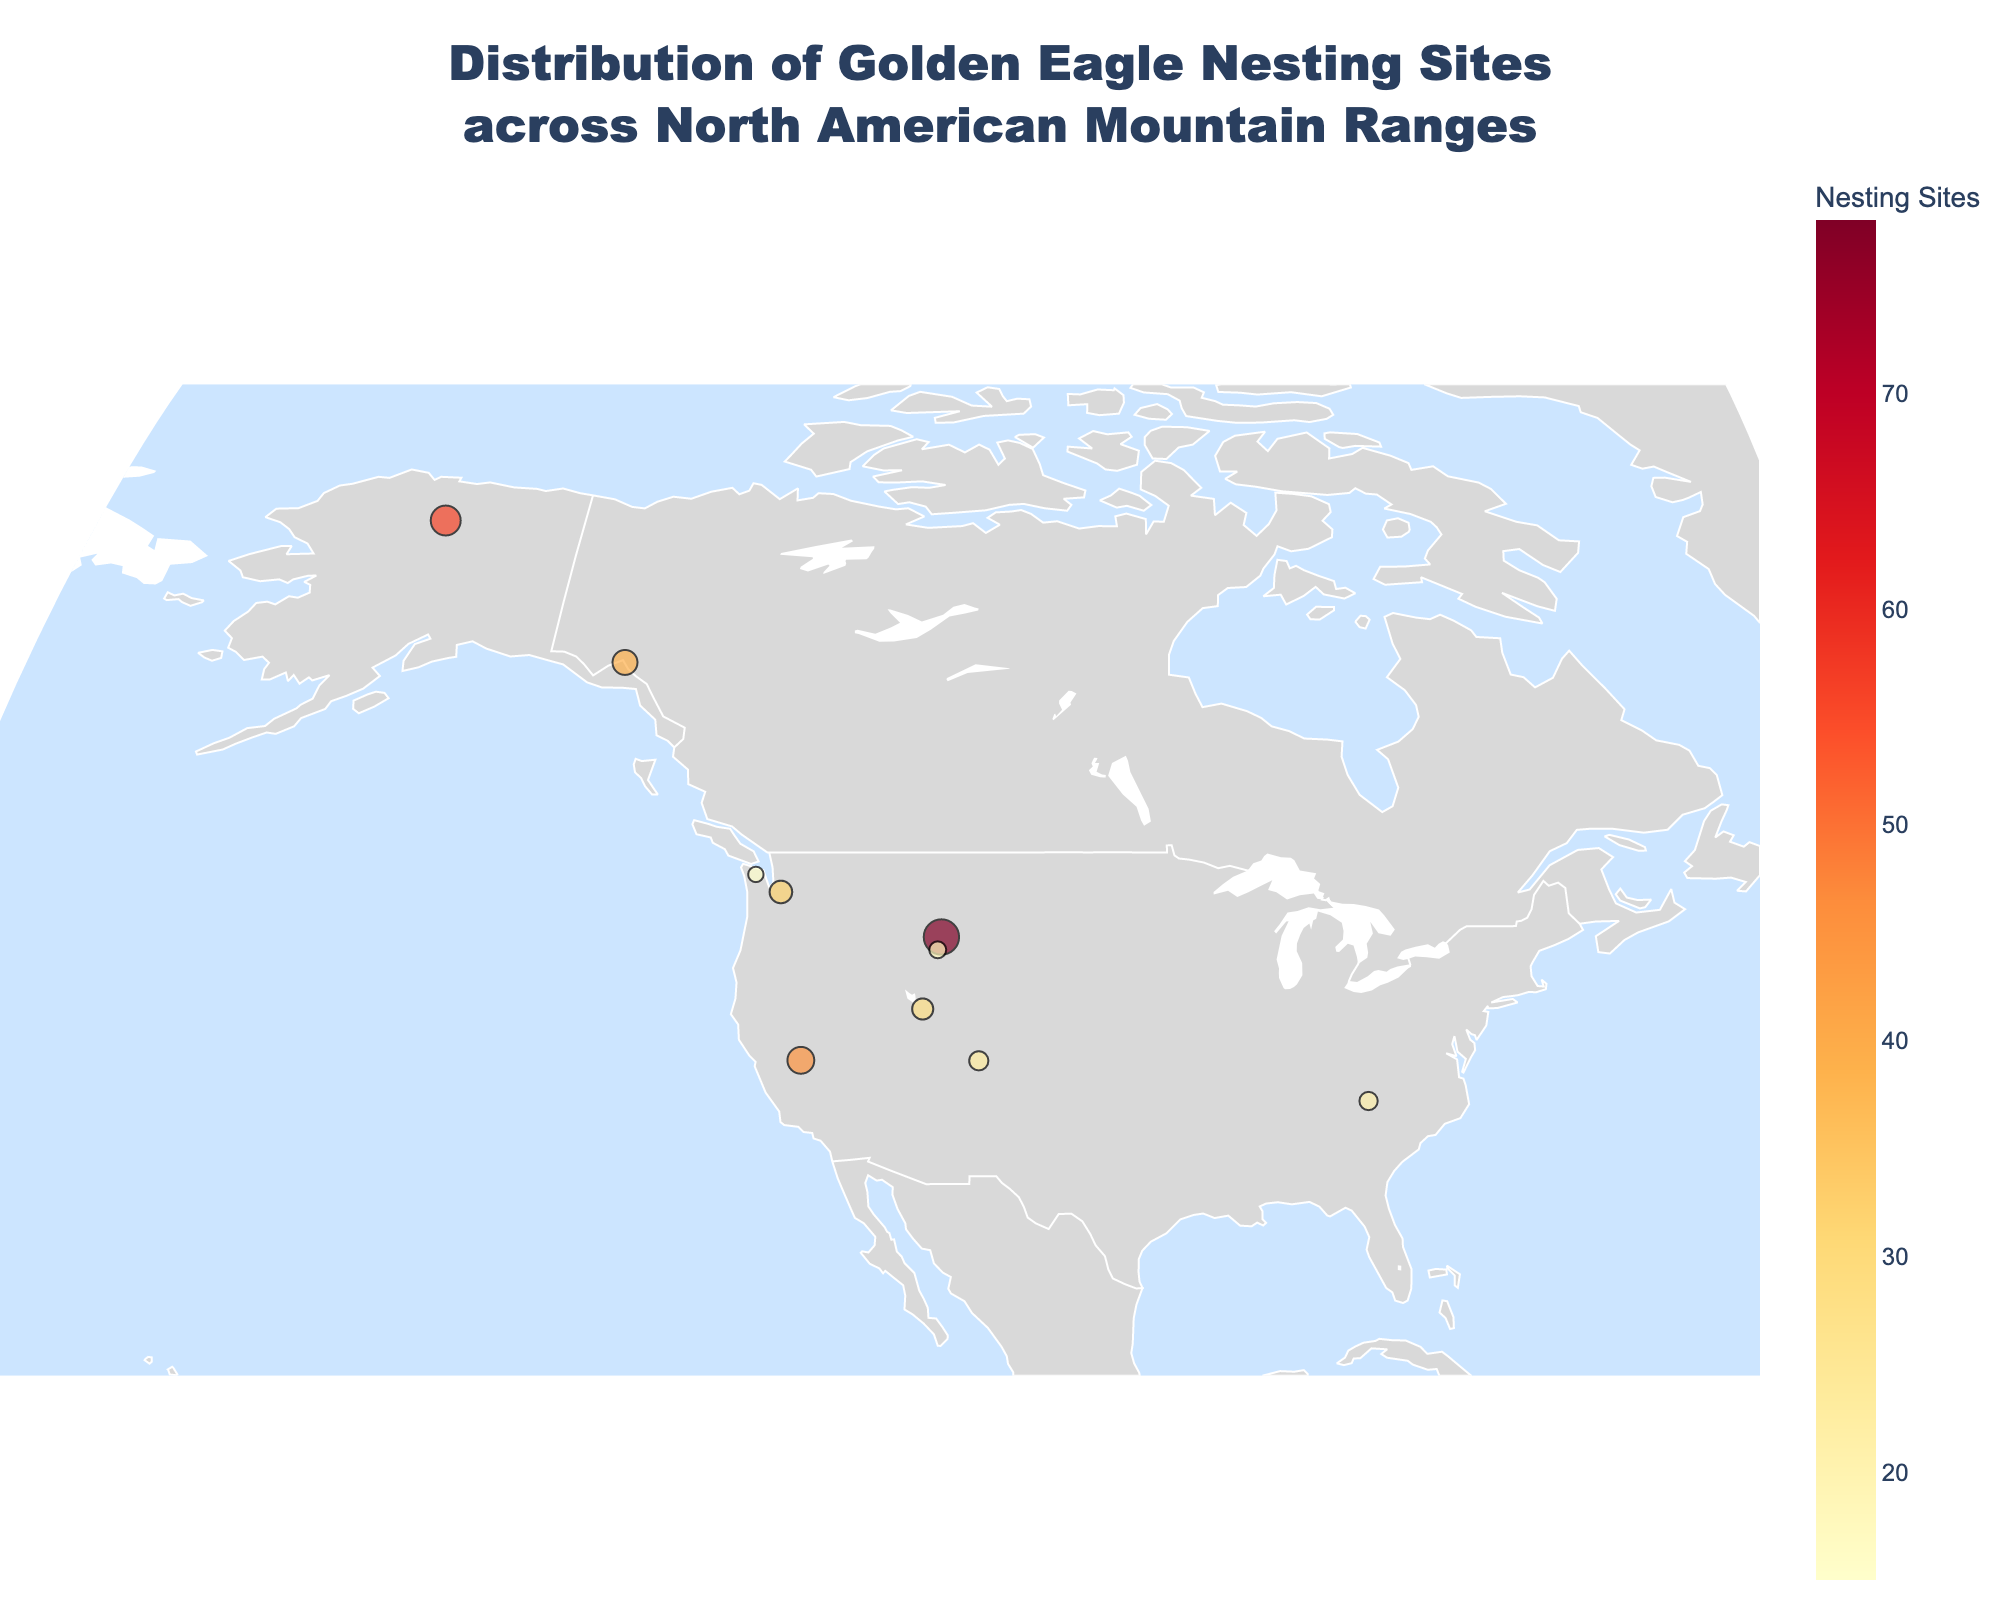What is the title of the figure? The title of the figure is usually displayed at the top and provides a summary of what the plot is about. Here, it mentions the distribution of golden eagle nesting sites.
Answer: Distribution of Golden Eagle Nesting Sites across North American Mountain Ranges Which mountain range has the highest number of golden eagle nesting sites? By looking at the sizes and colors of the markers, we can identify the mountain range with the largest and most intensely colored marker, which corresponds to the highest count of nesting sites.
Answer: Rocky Mountains How does the number of nesting sites in the Brooks Range compare to the Sierra Nevada? We need to compare the marker sizes and colors for the Brooks Range and Sierra Nevada. The Brooks Range has 56 nesting sites, while the Sierra Nevada has 45 nesting sites.
Answer: The Brooks Range has more nesting sites Which mountain range has the smallest number of golden eagle nesting sites? The mountain range with the smallest marker size and lightest color will have the least number of nesting sites.
Answer: Olympic Mountains What is the combined number of golden eagle nesting sites in the San Juan Mountains and the Teton Range? We need to add the number of nesting sites in the San Juan Mountains (23) and the Teton Range (18). 23 + 18 = 41.
Answer: 41 Which mountain ranges are represented by markers located furthest north and furthest south? For the furthest north, look for the marker at the highest latitude, and for the furthest south, look for the marker at the lowest latitude.
Answer: Furthest North: Brooks Range, Furthest South: Sierra Nevada How many mountain ranges have more than 30 nesting sites? We need to count how many mountain ranges have more than 30 nesting sites by checking each marker's size and color. The ranges are Rocky Mountains, Sierra Nevada, Cascade Range, and Brooks Range.
Answer: 4 What is the difference in the number of nesting sites between the Coast Mountains and the Wasatch Range? Subtract the number of nesting sites in the Wasatch Range (28) from those in the Coast Mountains (39). 39 - 28 = 11.
Answer: 11 Are there more nesting sites in the Appalachian Mountains or the Teton Range? Compare the number of nesting sites in both ranges. The Appalachian Mountains have 21 nesting sites and the Teton Range has 18.
Answer: Appalachian Mountains What is the average number of nesting sites across all the listed mountain ranges? Sum the number of nesting sites for all mountain ranges and divide by the total number of ranges. (78 + 45 + 32 + 21 + 56 + 39 + 28 + 15 + 23 + 18) / 10 = 35.5.
Answer: 35.5 